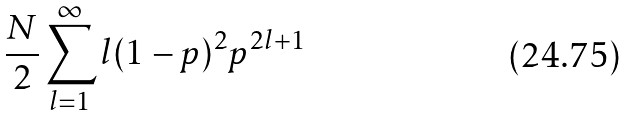Convert formula to latex. <formula><loc_0><loc_0><loc_500><loc_500>\frac { N } { 2 } \sum _ { l = 1 } ^ { \infty } l ( 1 - p ) ^ { 2 } p ^ { 2 l + 1 }</formula> 